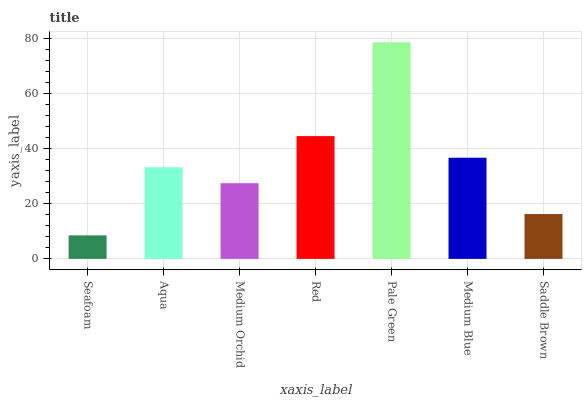Is Aqua the minimum?
Answer yes or no. No. Is Aqua the maximum?
Answer yes or no. No. Is Aqua greater than Seafoam?
Answer yes or no. Yes. Is Seafoam less than Aqua?
Answer yes or no. Yes. Is Seafoam greater than Aqua?
Answer yes or no. No. Is Aqua less than Seafoam?
Answer yes or no. No. Is Aqua the high median?
Answer yes or no. Yes. Is Aqua the low median?
Answer yes or no. Yes. Is Medium Blue the high median?
Answer yes or no. No. Is Medium Blue the low median?
Answer yes or no. No. 